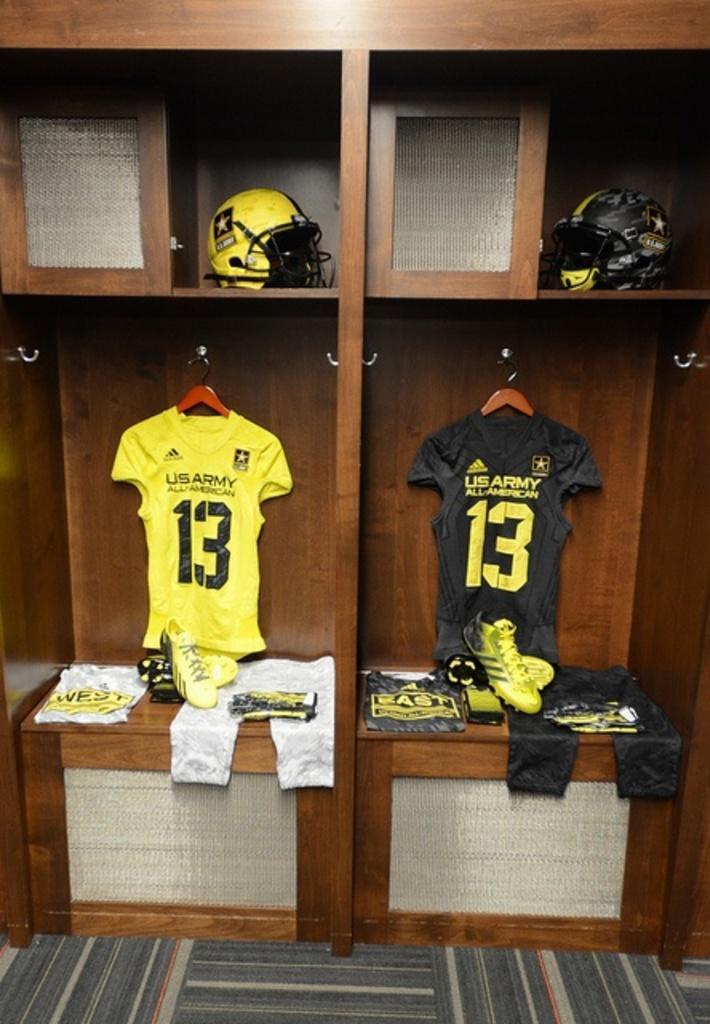Describe this image in one or two sentences. In a cabinet there are 2 sections. At the left there is a yellow helmet, yellow t shirt on the hanger, yellow shoes and shorts. At the right there is a black helmet, black t shirt on the hanger, yellow shoes and shorts. 